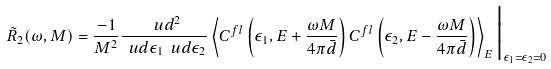Convert formula to latex. <formula><loc_0><loc_0><loc_500><loc_500>\tilde { R } _ { 2 } ( \omega , M ) = \frac { - 1 } { M ^ { 2 } } \frac { \ u d ^ { 2 } } { \ u d \epsilon _ { 1 } \ u d \epsilon _ { 2 } } \left \langle C ^ { f l } \left ( \epsilon _ { 1 } , E + \frac { \omega M } { 4 \pi \bar { d } } \right ) C ^ { f l } \left ( \epsilon _ { 2 } , E - \frac { \omega M } { 4 \pi \bar { d } } \right ) \right \rangle _ { E } \Big | _ { \epsilon _ { 1 } = \epsilon _ { 2 } = 0 }</formula> 